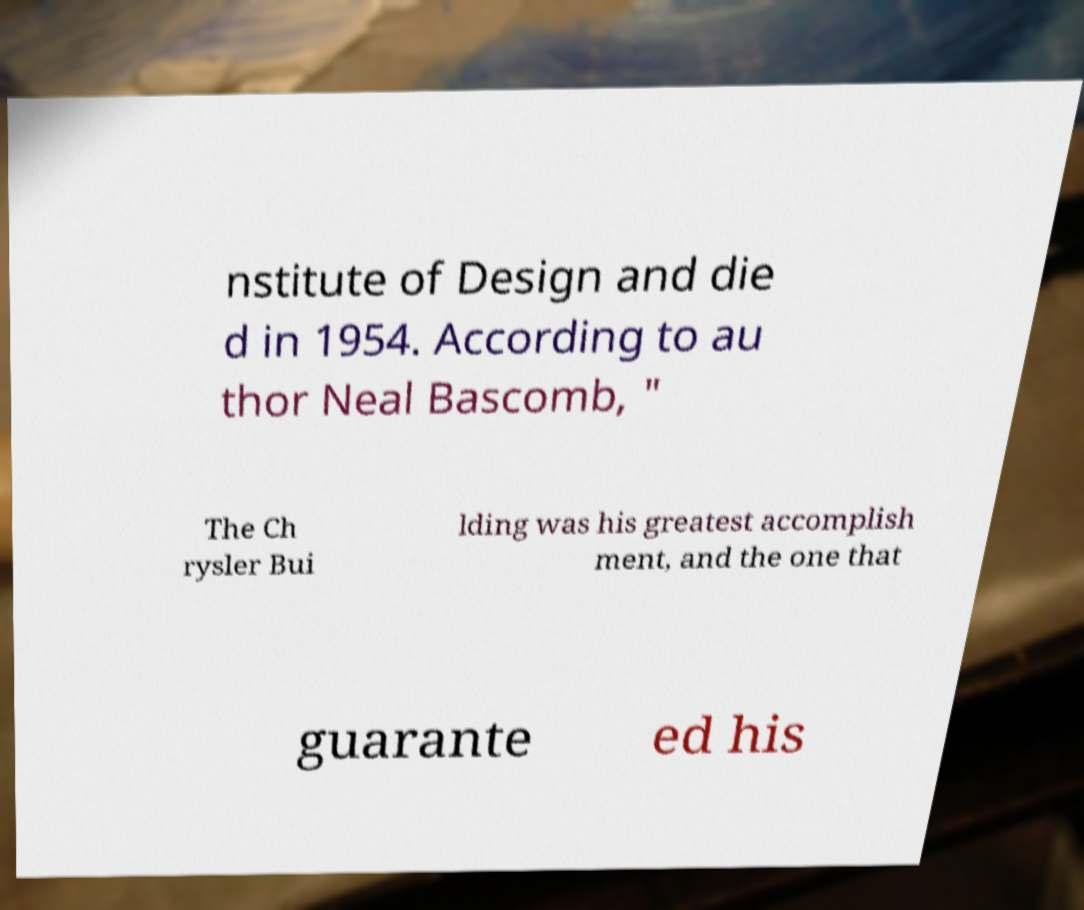Could you assist in decoding the text presented in this image and type it out clearly? nstitute of Design and die d in 1954. According to au thor Neal Bascomb, " The Ch rysler Bui lding was his greatest accomplish ment, and the one that guarante ed his 